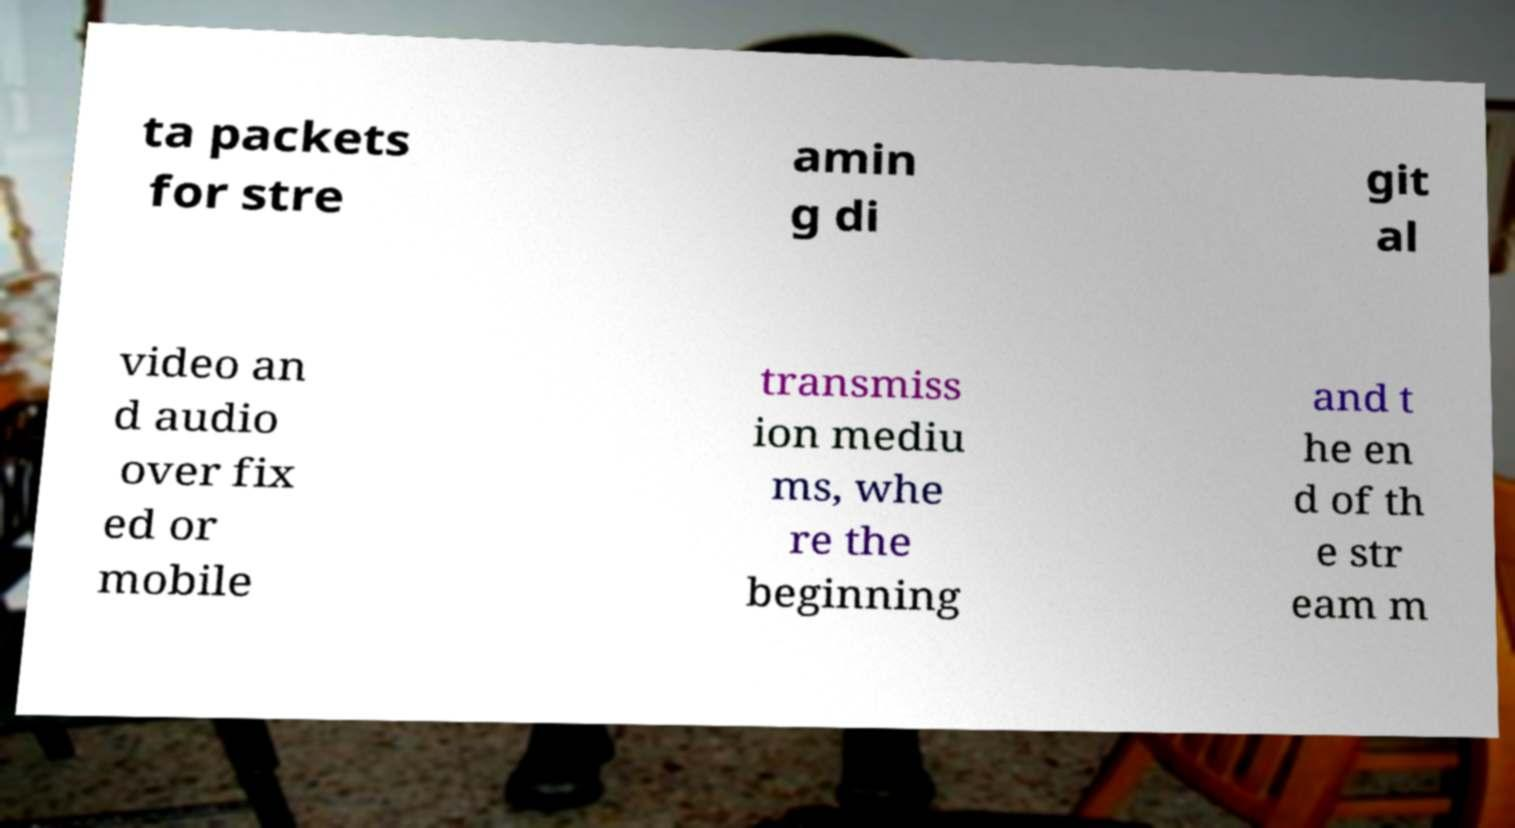Can you accurately transcribe the text from the provided image for me? ta packets for stre amin g di git al video an d audio over fix ed or mobile transmiss ion mediu ms, whe re the beginning and t he en d of th e str eam m 